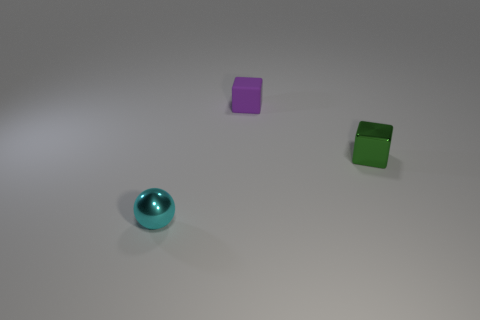Subtract all green blocks. How many blocks are left? 1 Add 1 metal blocks. How many objects exist? 4 Subtract all balls. How many objects are left? 2 Subtract 1 spheres. How many spheres are left? 0 Subtract all purple blocks. Subtract all red cylinders. How many blocks are left? 1 Subtract all cyan spheres. How many purple cubes are left? 1 Subtract all shiny objects. Subtract all tiny green objects. How many objects are left? 0 Add 3 tiny cyan shiny spheres. How many tiny cyan shiny spheres are left? 4 Add 2 cubes. How many cubes exist? 4 Subtract 0 yellow spheres. How many objects are left? 3 